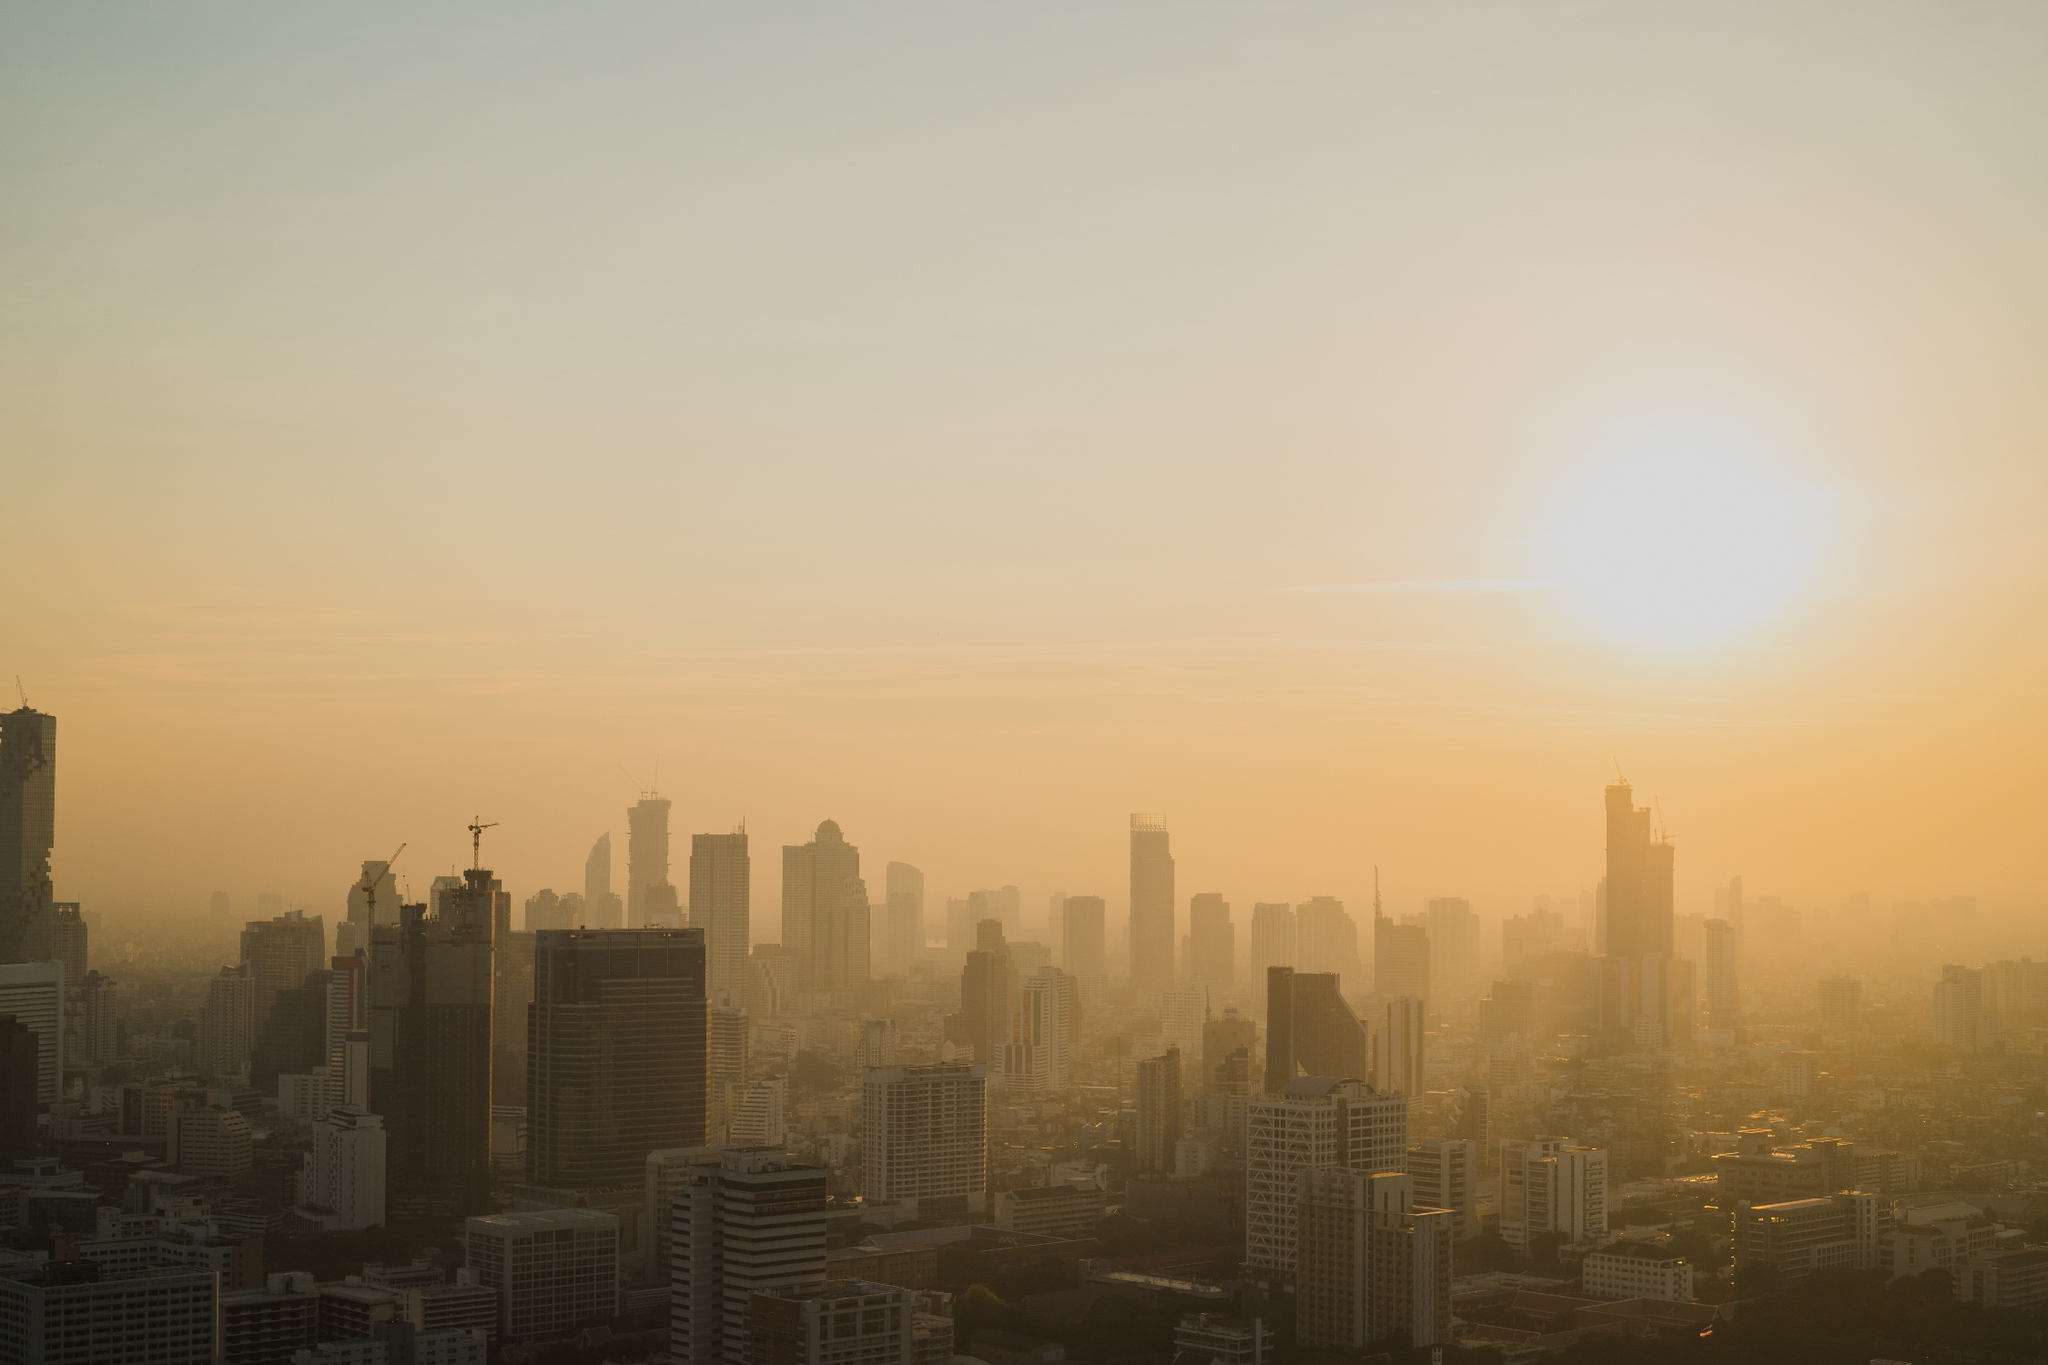Describe the architectural diversity in the image. The skyline showcases a tapestry of architectural styles, with modern glass-fronted skyscrapers standing alongside older, shorter buildings. This architectural diversity indicates the city's development over time and the blend of old and new structures. The construction cranes suggest ongoing development and the city's evolution. Without visible landmarks, how can we determine this city's identity? Identifying a city without clear landmarks can be challenging. However, one might deduce clues from the style of the buildings, the density and layout of the city, and the environmental context, such as smog, which can be indicative of large, industrialized cities in certain regions. 